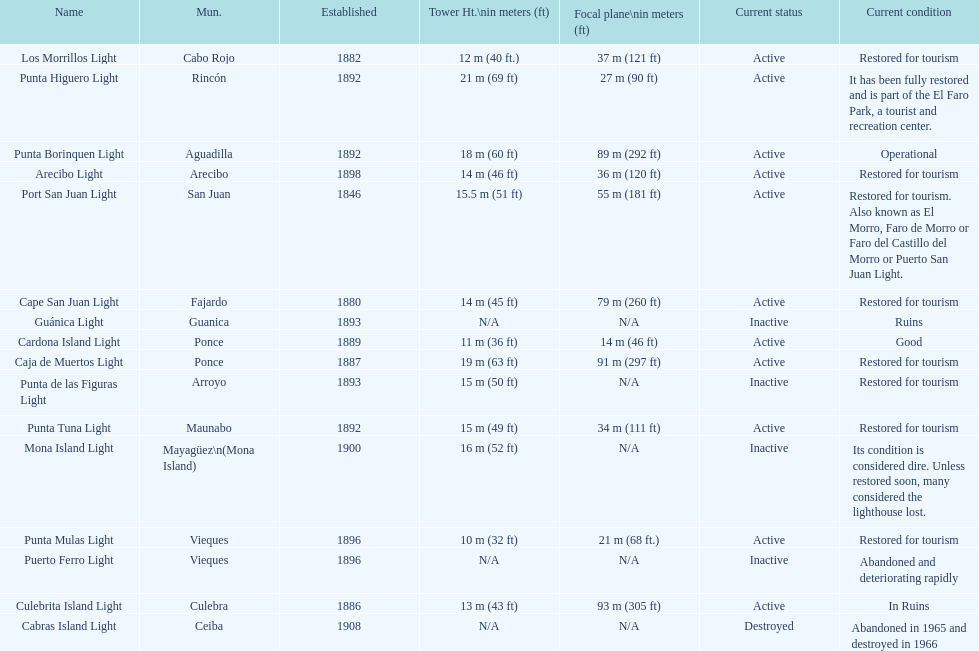Which municipality was the first to be established? San Juan. 